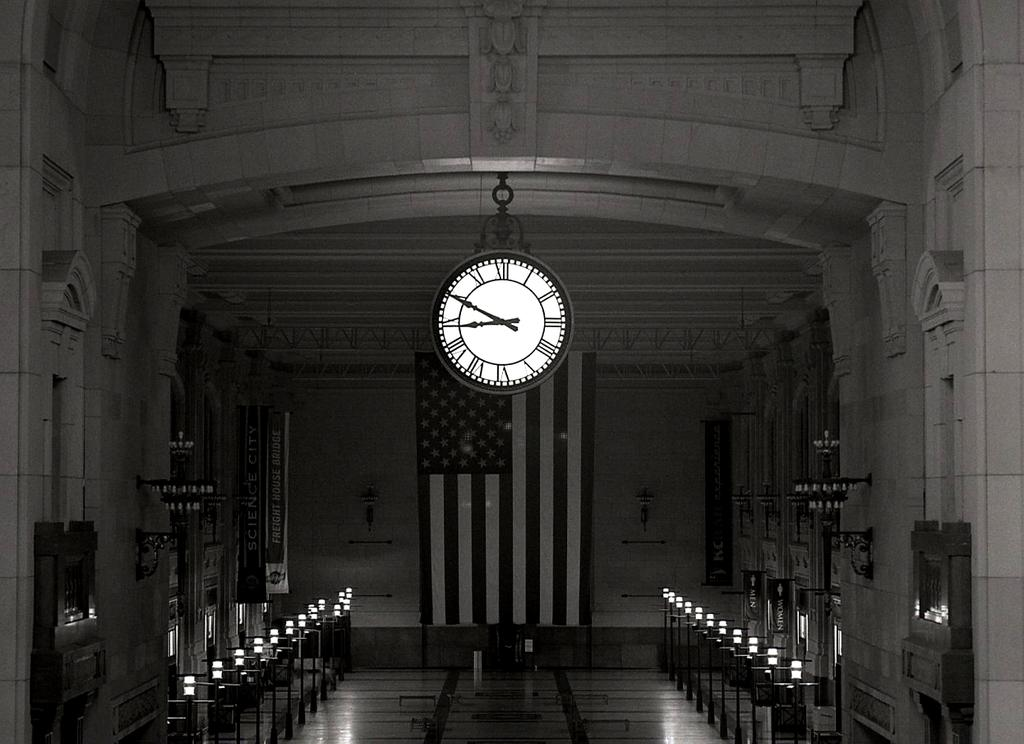<image>
Share a concise interpretation of the image provided. A sign with Science City written on it next to the American flag. 